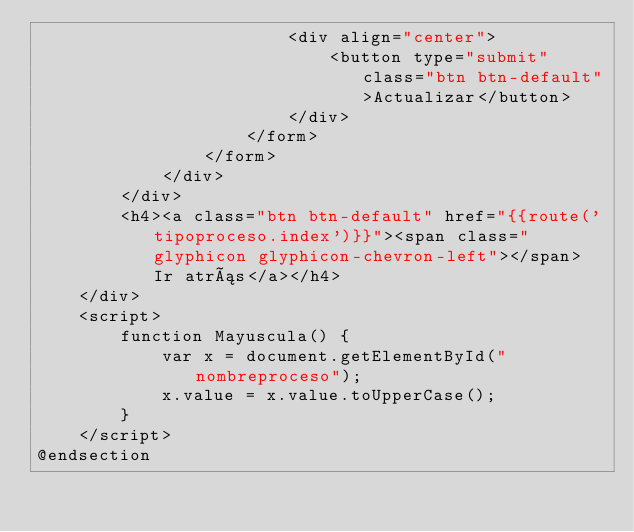<code> <loc_0><loc_0><loc_500><loc_500><_PHP_>                        <div align="center">
                            <button type="submit" class="btn btn-default">Actualizar</button>
                        </div>
                    </form>
                </form>
            </div>
        </div>
        <h4><a class="btn btn-default" href="{{route('tipoproceso.index')}}"><span class="glyphicon glyphicon-chevron-left"></span> Ir atrás</a></h4>
    </div>
    <script>
        function Mayuscula() {
            var x = document.getElementById("nombreproceso");
            x.value = x.value.toUpperCase();
        }
    </script>
@endsection</code> 